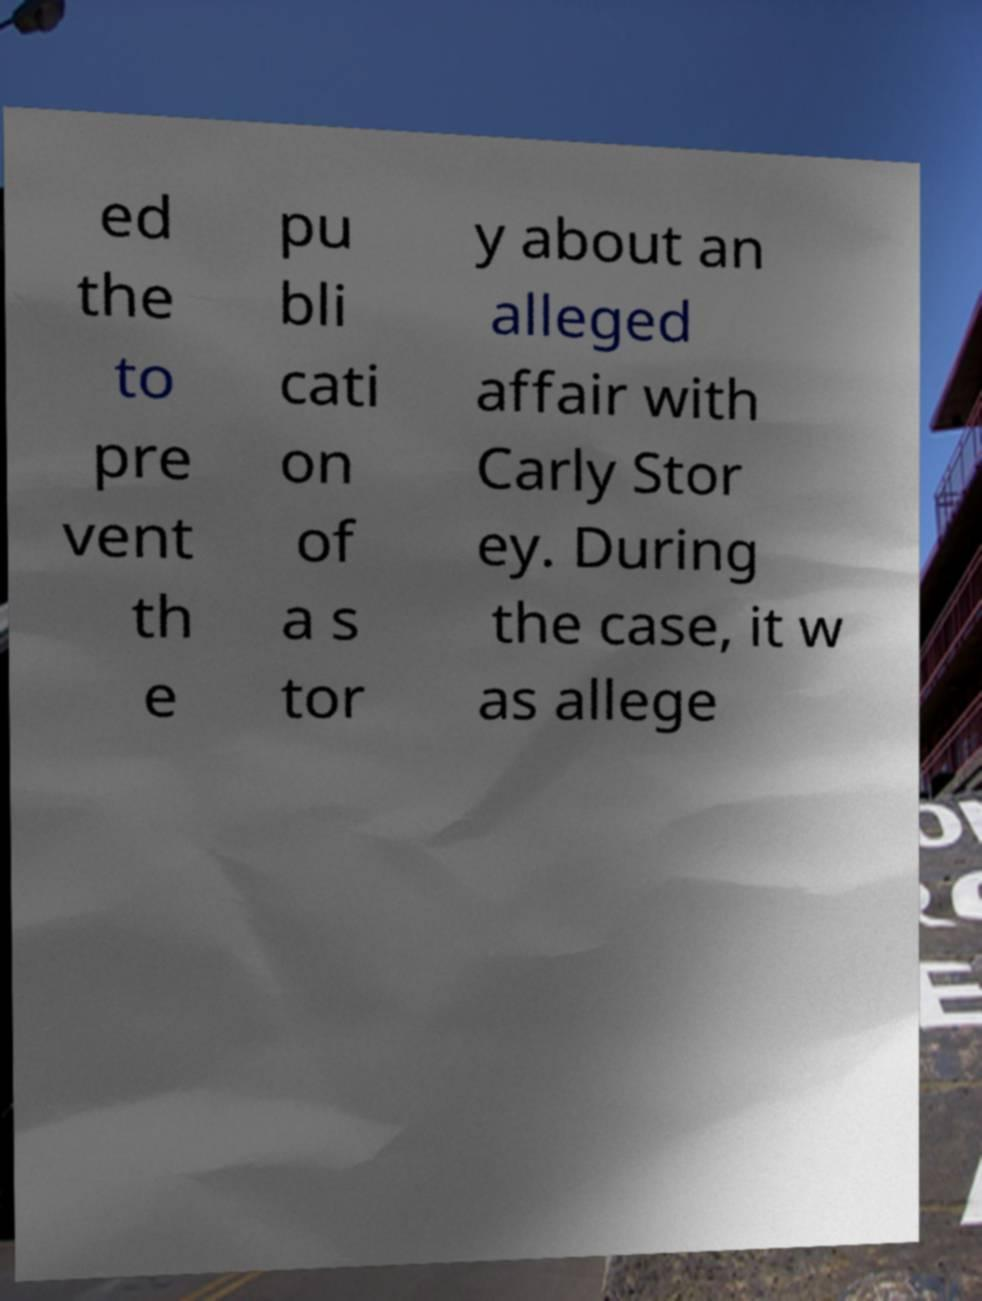What messages or text are displayed in this image? I need them in a readable, typed format. ed the to pre vent th e pu bli cati on of a s tor y about an alleged affair with Carly Stor ey. During the case, it w as allege 